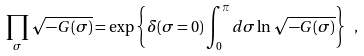Convert formula to latex. <formula><loc_0><loc_0><loc_500><loc_500>\prod _ { \sigma } \sqrt { - G ( \sigma ) } = \exp \left \{ \delta ( \sigma = 0 ) \int _ { 0 } ^ { \pi } d \sigma \ln \sqrt { - G ( \sigma ) } \right \} \ ,</formula> 